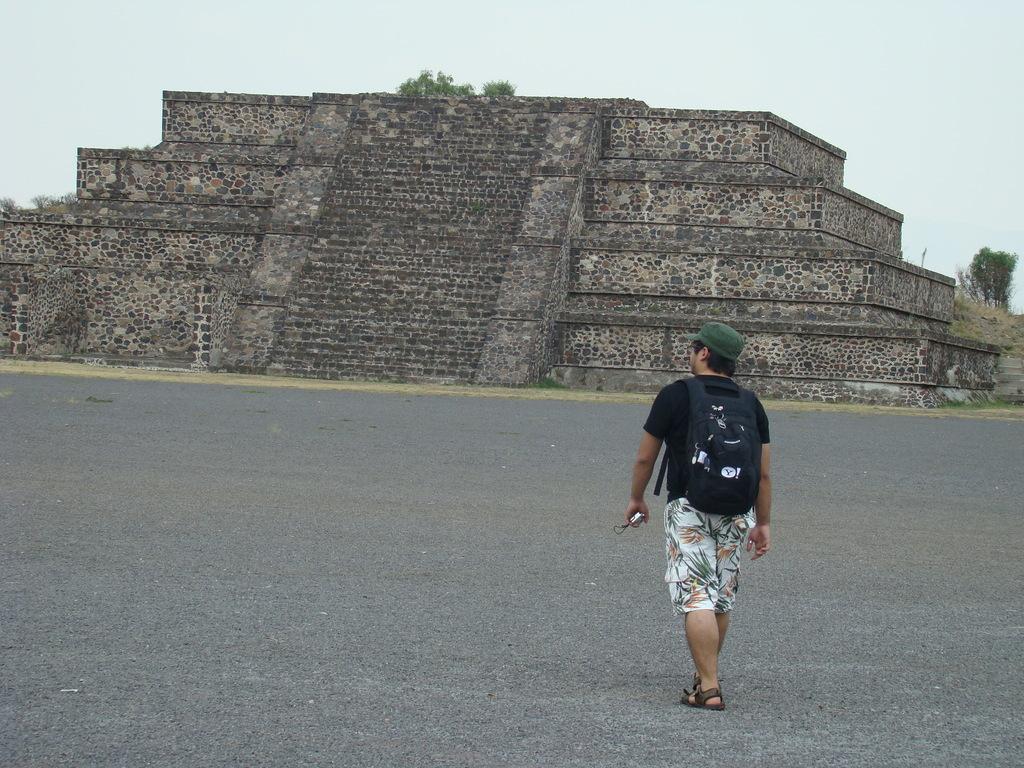Could you give a brief overview of what you see in this image? This image is clicked outside. There are trees on the right side. There is sky at the top. There is a person walking in the middle. He is wearing backpack and a cap. 